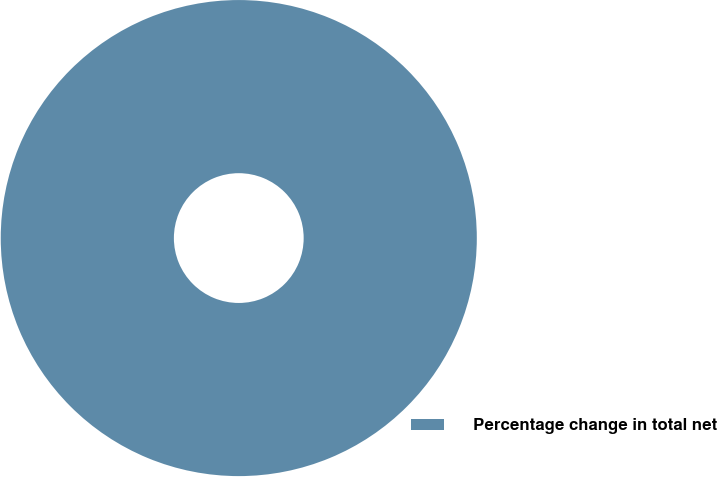Convert chart to OTSL. <chart><loc_0><loc_0><loc_500><loc_500><pie_chart><fcel>Percentage change in total net<nl><fcel>100.0%<nl></chart> 